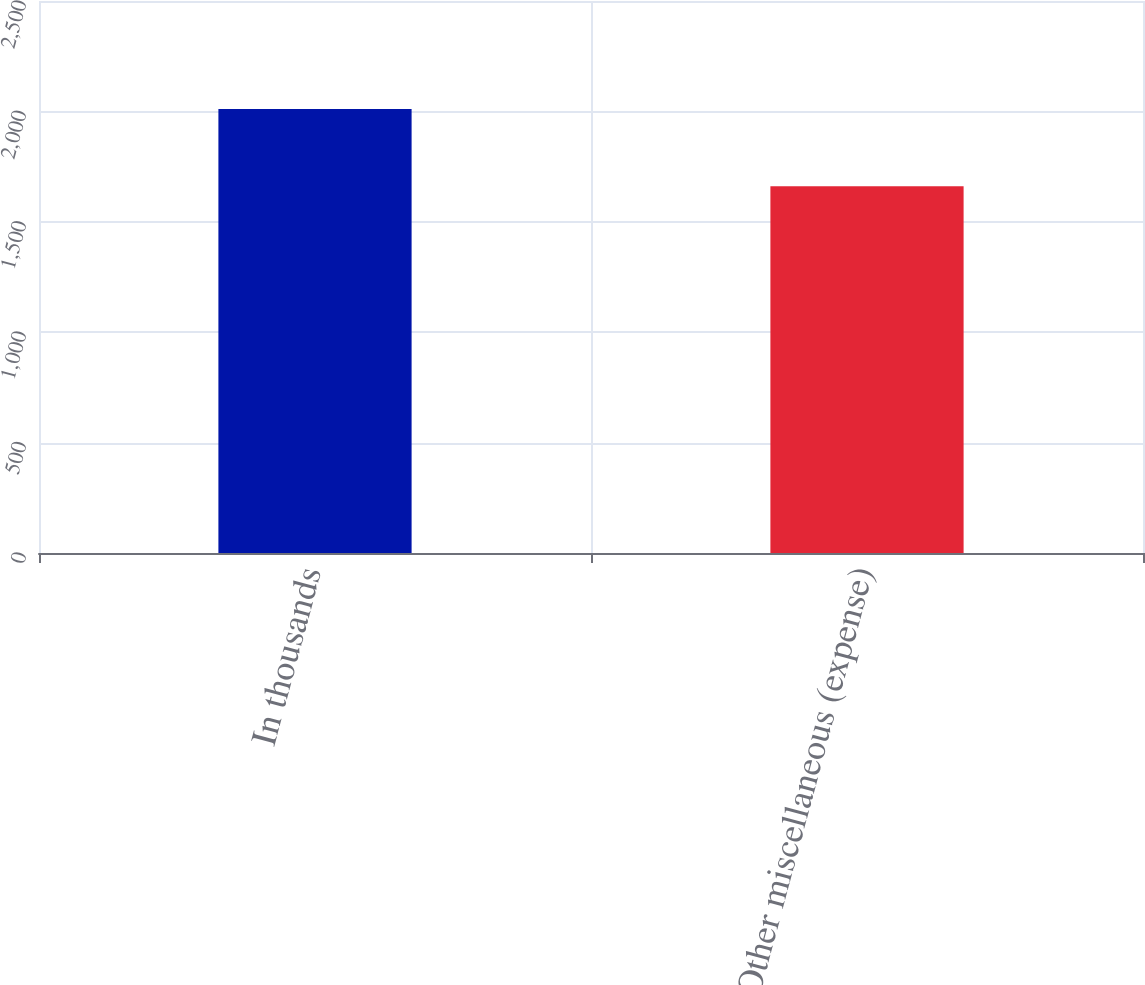Convert chart. <chart><loc_0><loc_0><loc_500><loc_500><bar_chart><fcel>In thousands<fcel>Other miscellaneous (expense)<nl><fcel>2011<fcel>1661<nl></chart> 